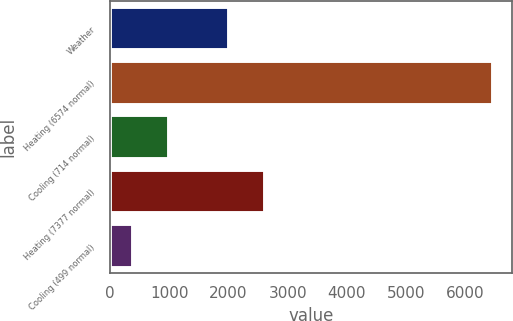Convert chart. <chart><loc_0><loc_0><loc_500><loc_500><bar_chart><fcel>Weather<fcel>Heating (6574 normal)<fcel>Cooling (714 normal)<fcel>Heating (7377 normal)<fcel>Cooling (499 normal)<nl><fcel>2015<fcel>6468<fcel>1003.2<fcel>2622.2<fcel>396<nl></chart> 